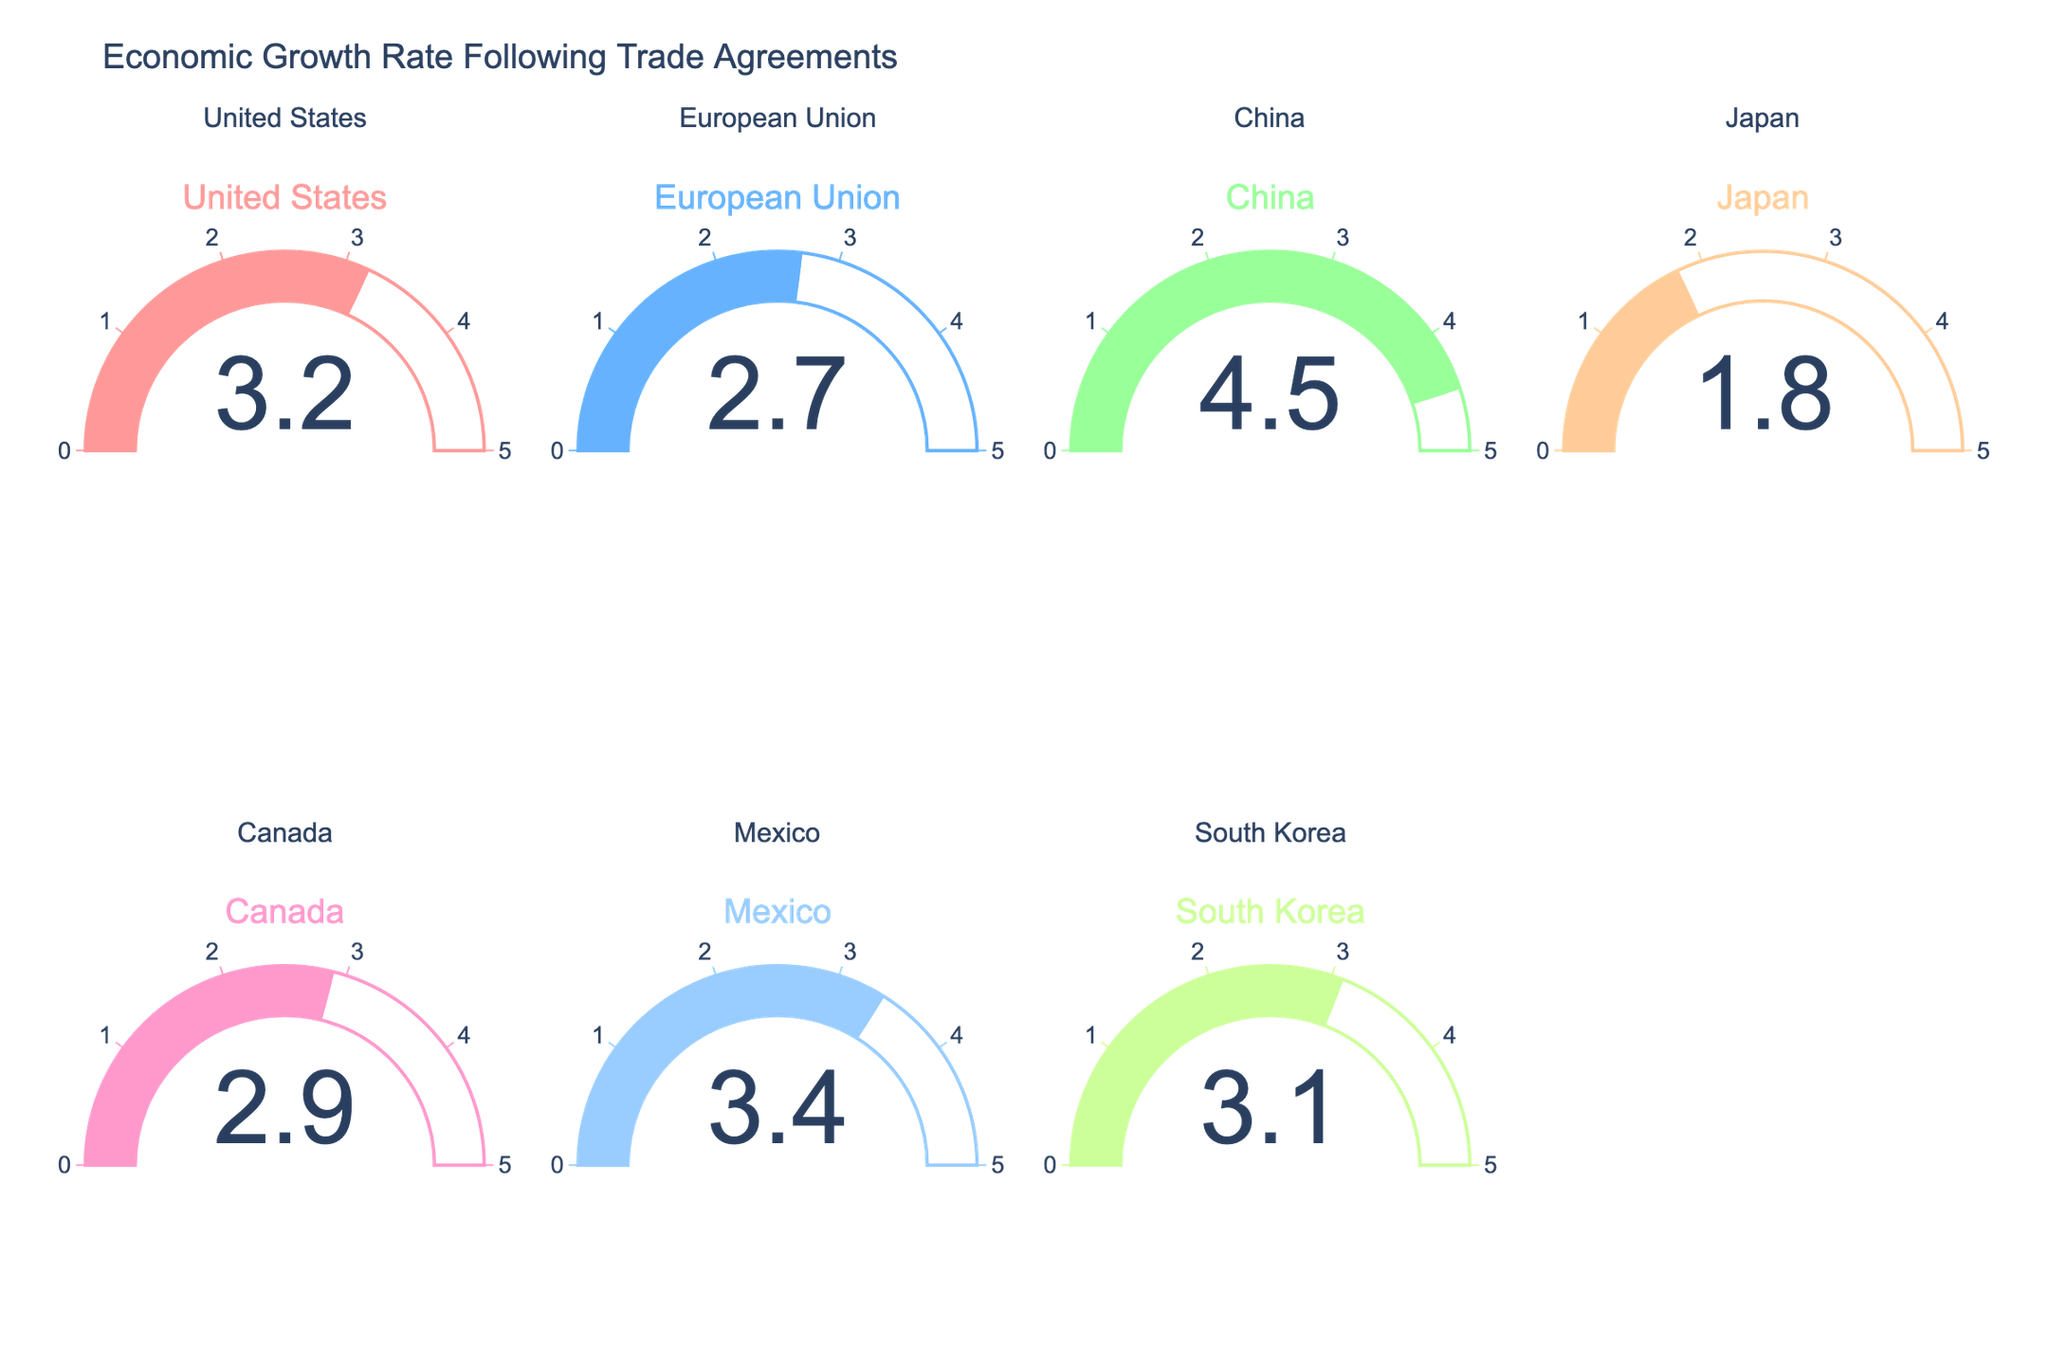what is the economic growth rate of china on the gauge chart the gauge chart has a title indicating china, and its pointer indicates a specific number on the scale
Answer: 4.5% which country has the lowest economic growth rate on the chart compare all the values indicated by the gauges, the gauge for japan reads the smallest number
Answer: japan what is the combined economic growth rate of the united states and mexico refer to the values for the united states and mexico, the gauges show 3.2% and 3.4% respectively. sum these values
Answer: 6.6% how much higher is china's economic growth rate compared to japan's compare the values of the gauges for china and japan, 4.5% and 1.8% respectively. subtract japan's value from china's
Answer: 2.7% which gauge shows the highest economic growth rate examine the highest values on the gauges. the gauge for china reads the highest number
Answer: china among the countries displayed, which one has an economic growth rate closest to 3% identify the gauges with values around 3%, south korea's gauge reads 3.1%
Answer: south korea what is the average economic growth rate of the european union, japan, and canada find the values for these countries' gauges. for the eu, japan, and canada, the values are 2.7%, 1.8%, and 2.9% respectively. calculate the average: (2.7 + 1.8 + 2.9) / 3
Answer: 2.47% how many countries have an economic growth rate above 3% count the gauges with values that surpass 3%. the united states, china, mexico, and south korea meet this criterion
Answer: 4 what is the difference between the economic growth rates of canada and mexico compare the values on the gauges for canada and mexico, which are 2.9% and 3.4% respectively. subtract canada's value from mexico's
Answer: 0.5% identify the country with an economic growth rate greater than japan but less than canada check gauges for rates that fall between japan's 1.8% and canada's 2.9%. the eu's rate is 2.7%
Answer: european union 